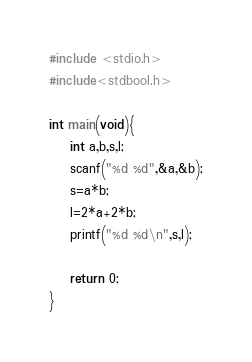<code> <loc_0><loc_0><loc_500><loc_500><_C_>#include <stdio.h>
#include<stdbool.h>

int main(void){
    int a,b,s,l;
    scanf("%d %d",&a,&b);
    s=a*b;
    l=2*a+2*b;
    printf("%d %d\n",s,l);
    
    return 0;
}
</code> 